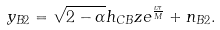<formula> <loc_0><loc_0><loc_500><loc_500>y _ { B 2 } = \sqrt { 2 - \alpha } h _ { C B } z e ^ { \frac { \iota \pi } { M } } + n _ { B 2 } .</formula> 